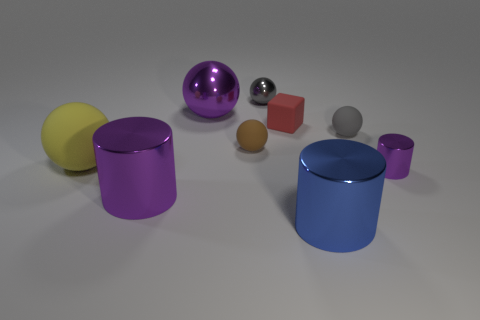How many gray balls must be subtracted to get 1 gray balls? 1 Subtract 1 spheres. How many spheres are left? 4 Subtract all brown spheres. How many spheres are left? 4 Subtract all purple spheres. How many spheres are left? 4 Subtract all brown cubes. Subtract all gray cylinders. How many cubes are left? 1 Add 1 green cylinders. How many objects exist? 10 Subtract all balls. How many objects are left? 4 Subtract all purple metal cylinders. Subtract all tiny gray shiny things. How many objects are left? 6 Add 1 big blue objects. How many big blue objects are left? 2 Add 5 yellow cylinders. How many yellow cylinders exist? 5 